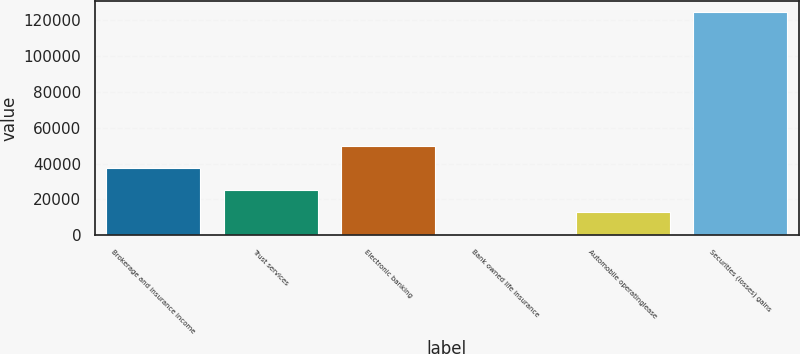<chart> <loc_0><loc_0><loc_500><loc_500><bar_chart><fcel>Brokerage and insurance income<fcel>Trust services<fcel>Electronic banking<fcel>Bank owned life insurance<fcel>Automobile operatinglease<fcel>Securities (losses) gains<nl><fcel>37678.6<fcel>25278.4<fcel>50078.8<fcel>478<fcel>12878.2<fcel>124480<nl></chart> 